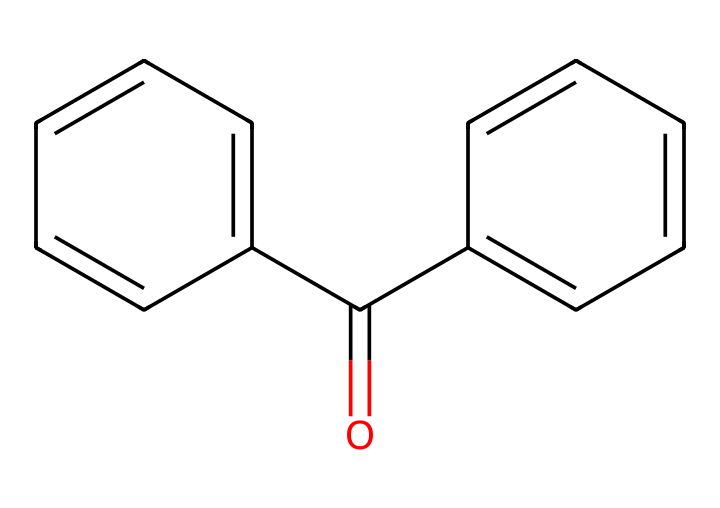What is the molecular formula of benzophenone? The SMILES representation indicates the presence of 15 carbons (C), 10 hydrogens (H), and 2 oxygens (O). Therefore, the molecular formula can be derived as C15H10O.
Answer: C15H10O How many aromatic rings are present in the structure? The chemical contains two distinct aromatic rings (the two separate benzene rings), which can be identified as the cyclical carbon chains connected by carbonyl functionality.
Answer: 2 What functional group is present in benzophenone? Looking at the structure, the carbonyl group (C=O) signifies the presence of a ketone functional group in benzophenone.
Answer: ketone What is the significance of benzophenone being a photosensitizer? Benzophenone's structure allows it to absorb UV light; this property is essential for its role in initiating polymerization in UV-curable coatings upon exposure to light.
Answer: absorbs UV light How many total bonds are in the molecule? Examining the structure, each aromatic ring contributes to several bonds, along with the carbonyl bond (C=O). Adding these gives a total of 14 bonds in the entire molecule.
Answer: 14 How many hydrogens are attached to each benzene ring? Each benzene ring in benzophenone has 5 attached hydrogens, as they have one hydrogen replaced by the carbonyl and one hydrogen bonding with the other ring.
Answer: 5 